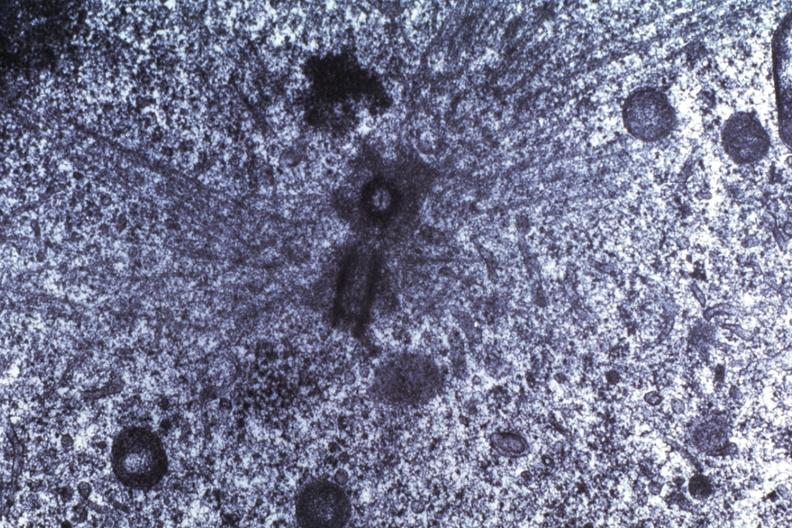s 70yof present?
Answer the question using a single word or phrase. No 